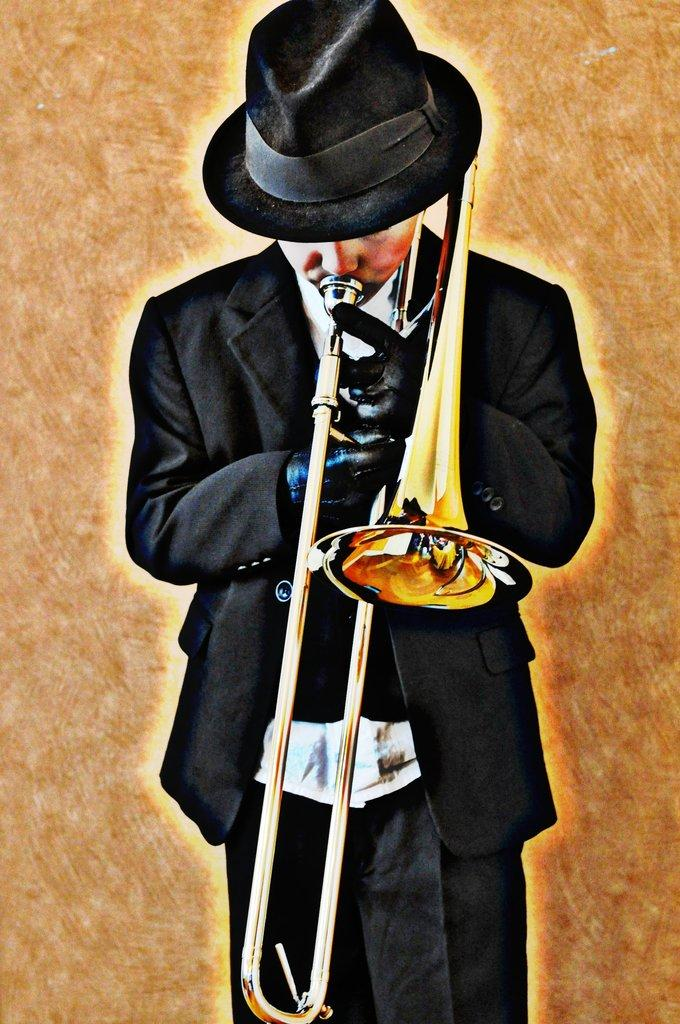What is the main subject of the image? The main subject of the image is a man. What is the man doing in the image? The man is playing a music instrument in the image. Can you describe the man's attire in the image? The man is wearing a black costume in the image. What type of cap is the man wearing during the battle in the image? There is no battle present in the image, and the man is not wearing a cap. 